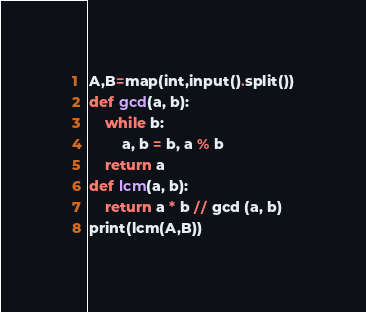<code> <loc_0><loc_0><loc_500><loc_500><_Python_>A,B=map(int,input().split())
def gcd(a, b):
	while b:
		a, b = b, a % b
	return a
def lcm(a, b):
	return a * b // gcd (a, b)
print(lcm(A,B))
</code> 